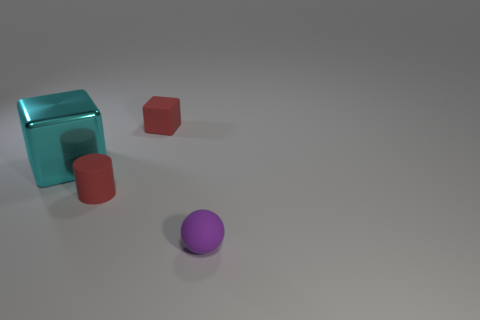Subtract 1 balls. How many balls are left? 0 Add 3 tiny red rubber cubes. How many objects exist? 7 Subtract all red cubes. How many cubes are left? 1 Subtract all balls. How many objects are left? 3 Subtract all red cylinders. How many red cubes are left? 1 Subtract all big cyan things. Subtract all big cyan metallic cubes. How many objects are left? 2 Add 2 cyan cubes. How many cyan cubes are left? 3 Add 3 big gray shiny cylinders. How many big gray shiny cylinders exist? 3 Subtract 0 brown balls. How many objects are left? 4 Subtract all gray balls. Subtract all gray cylinders. How many balls are left? 1 